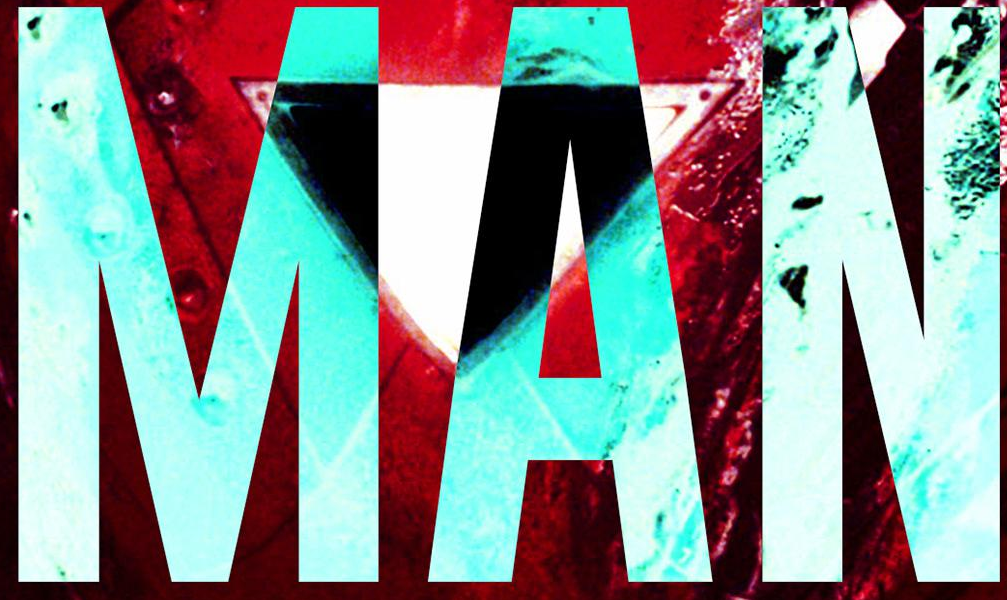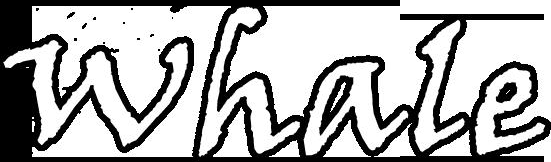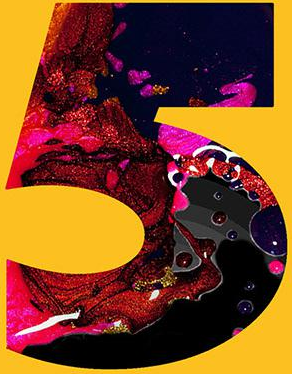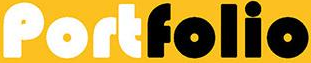Read the text content from these images in order, separated by a semicolon. MAN; whale; 5; Portfolio 